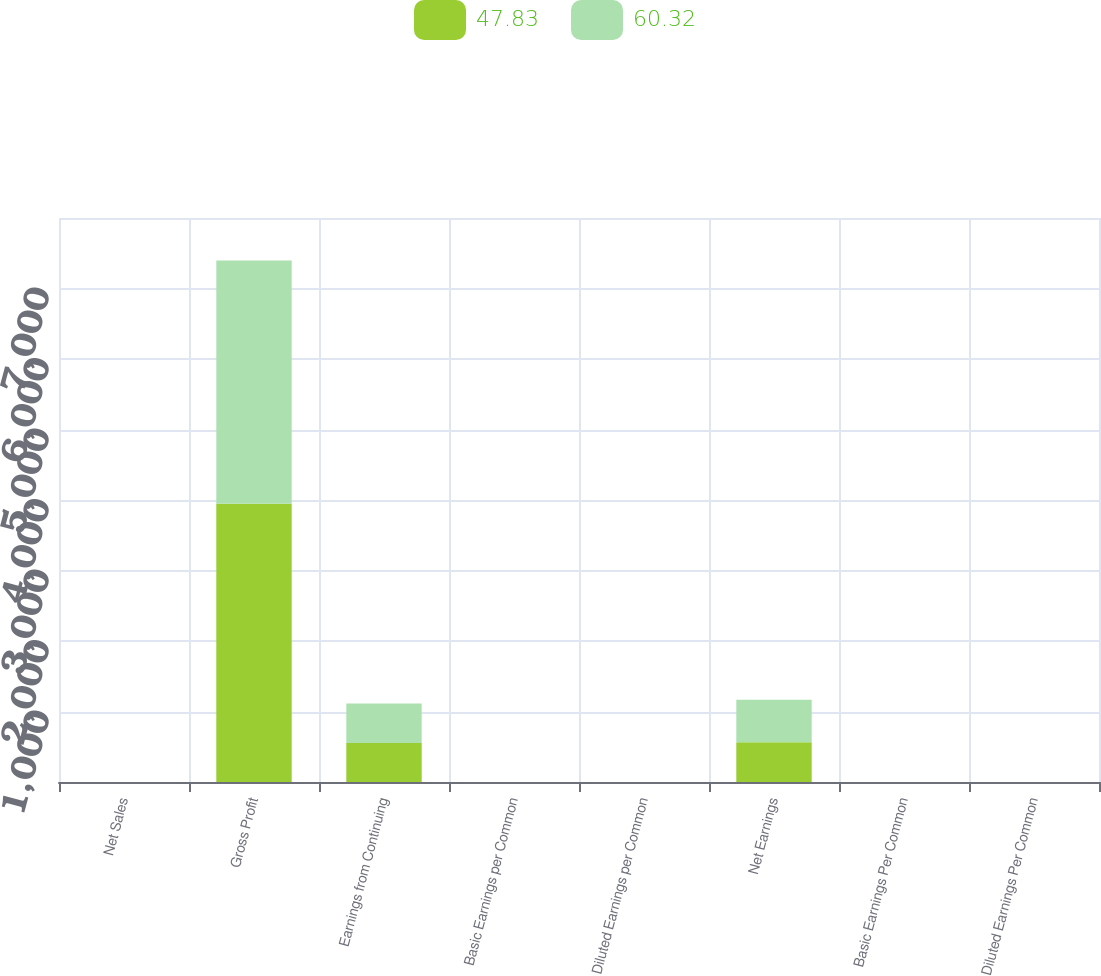Convert chart. <chart><loc_0><loc_0><loc_500><loc_500><stacked_bar_chart><ecel><fcel>Net Sales<fcel>Gross Profit<fcel>Earnings from Continuing<fcel>Basic Earnings per Common<fcel>Diluted Earnings per Common<fcel>Net Earnings<fcel>Basic Earnings Per Common<fcel>Diluted Earnings Per Common<nl><fcel>47.83<fcel>0.34<fcel>3946<fcel>552<fcel>0.31<fcel>0.31<fcel>563<fcel>0.32<fcel>0.32<nl><fcel>60.32<fcel>0.34<fcel>3452<fcel>561<fcel>0.32<fcel>0.32<fcel>603<fcel>0.34<fcel>0.34<nl></chart> 